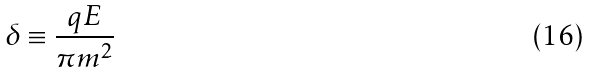Convert formula to latex. <formula><loc_0><loc_0><loc_500><loc_500>\delta \equiv \frac { q E } { \pi m ^ { 2 } }</formula> 